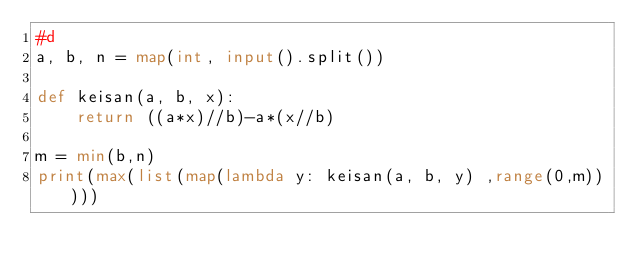Convert code to text. <code><loc_0><loc_0><loc_500><loc_500><_Python_>#d
a, b, n = map(int, input().split())

def keisan(a, b, x):
    return ((a*x)//b)-a*(x//b)

m = min(b,n)
print(max(list(map(lambda y: keisan(a, b, y) ,range(0,m)))))</code> 